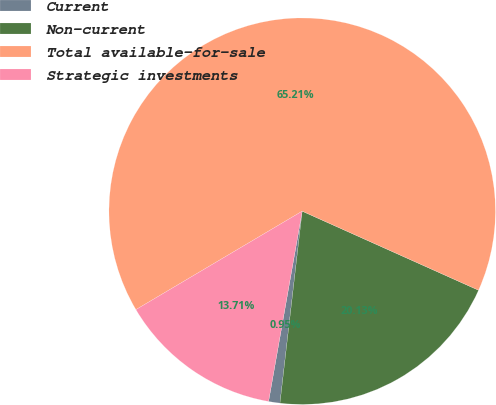Convert chart to OTSL. <chart><loc_0><loc_0><loc_500><loc_500><pie_chart><fcel>Current<fcel>Non-current<fcel>Total available-for-sale<fcel>Strategic investments<nl><fcel>0.95%<fcel>20.13%<fcel>65.22%<fcel>13.71%<nl></chart> 